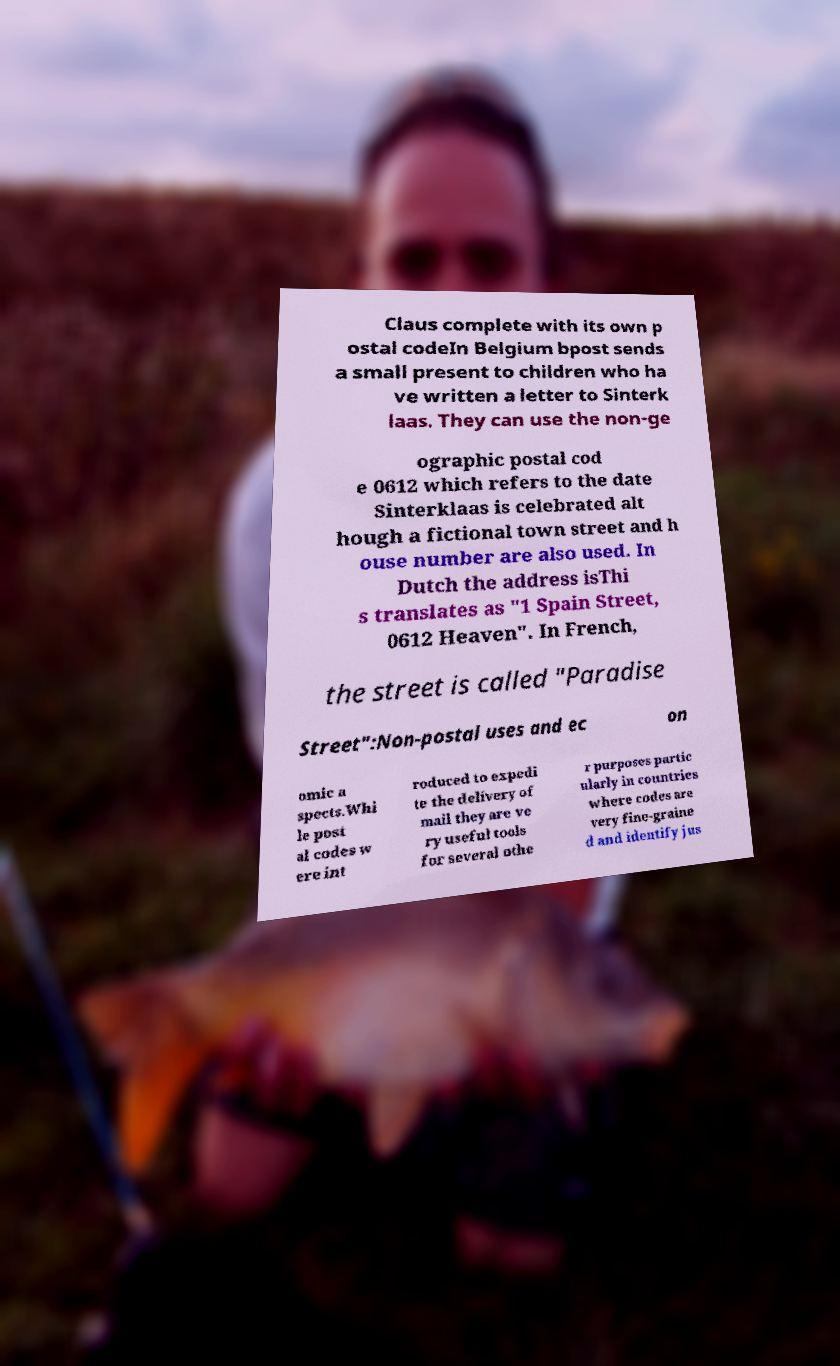Please read and relay the text visible in this image. What does it say? Claus complete with its own p ostal codeIn Belgium bpost sends a small present to children who ha ve written a letter to Sinterk laas. They can use the non-ge ographic postal cod e 0612 which refers to the date Sinterklaas is celebrated alt hough a fictional town street and h ouse number are also used. In Dutch the address isThi s translates as "1 Spain Street, 0612 Heaven". In French, the street is called "Paradise Street":Non-postal uses and ec on omic a spects.Whi le post al codes w ere int roduced to expedi te the delivery of mail they are ve ry useful tools for several othe r purposes partic ularly in countries where codes are very fine-graine d and identify jus 